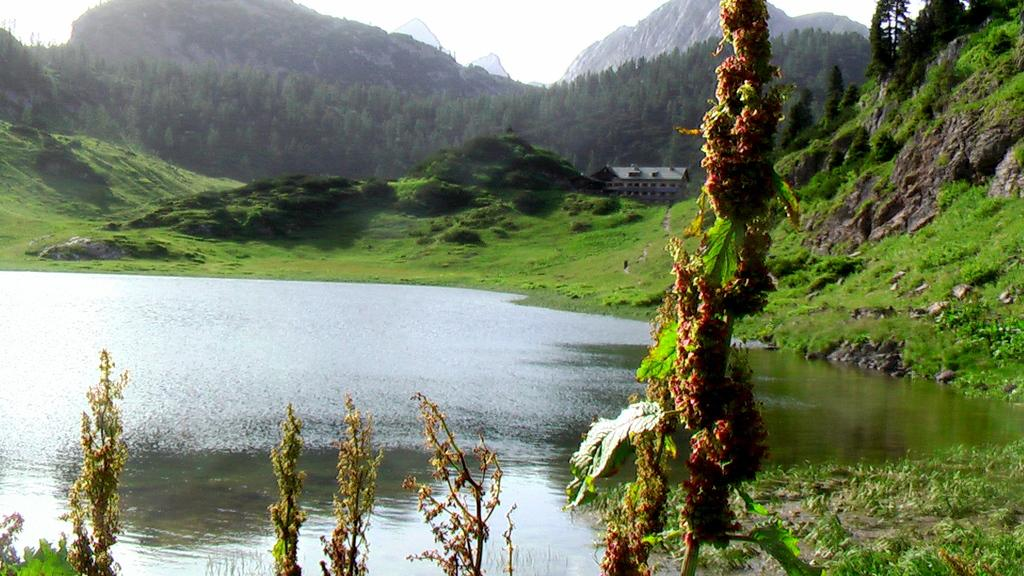What type of natural landform can be seen in the image? There are mountains in the image. What type of vegetation is present in the image? There are trees in the image. What type of man-made structure is visible in the image? There is a building in the image. What can be seen at the bottom of the image? There is water and grass visible at the bottom of the image. What is visible at the top of the image? The sky is visible at the top of the image. What type of collar can be seen on the tree in the image? There is no collar present on the tree in the image. What type of tank is visible in the image? There is no tank present in the image. 